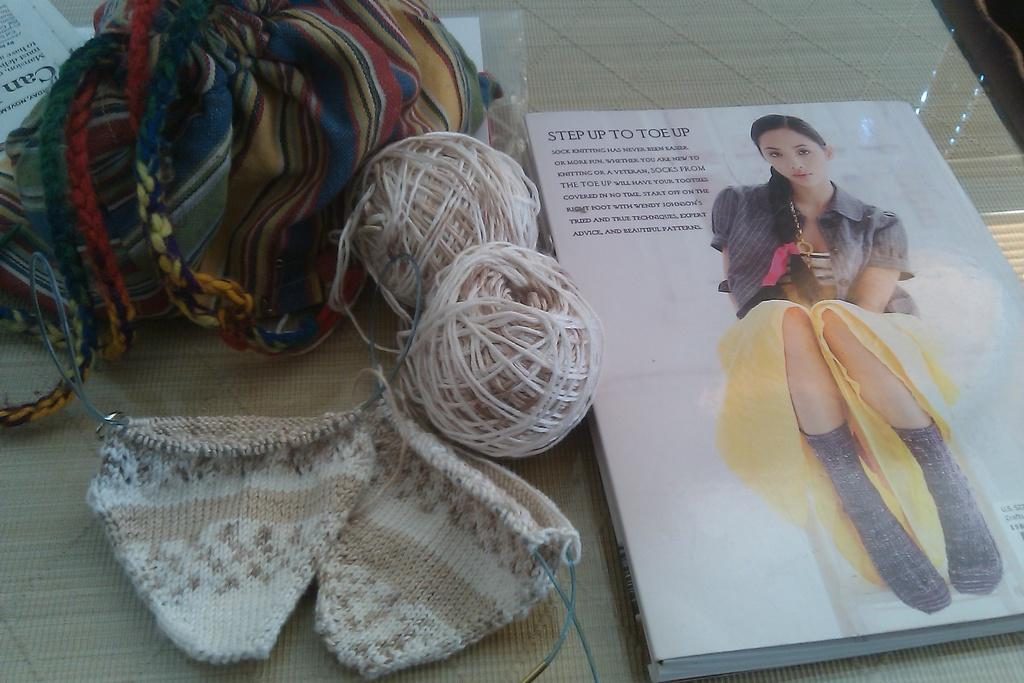What is placed on the table in the image? There is a book, a wool roll, cloth, and papers on the table. Can you describe the materials of the items on the table? The book is made of paper, the wool roll is made of wool, and the cloth is made of fabric. How many items are on the table? There are four items on the table: a book, a wool roll, cloth, and papers. What type of hose is connected to the committee in the image? There is no hose or committee present in the image; the image only features a book, a wool roll, cloth, and papers on a table. 